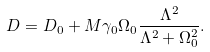<formula> <loc_0><loc_0><loc_500><loc_500>D = D _ { 0 } + M \gamma _ { 0 } \Omega _ { 0 } \frac { \Lambda ^ { 2 } } { \Lambda ^ { 2 } + \Omega _ { 0 } ^ { 2 } } .</formula> 